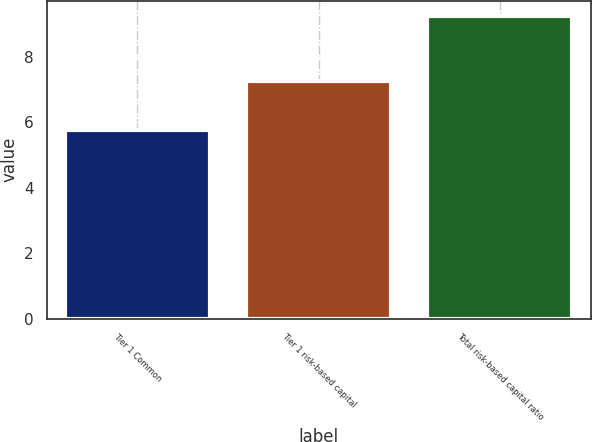Convert chart. <chart><loc_0><loc_0><loc_500><loc_500><bar_chart><fcel>Tier 1 Common<fcel>Tier 1 risk-based capital<fcel>Total risk-based capital ratio<nl><fcel>5.75<fcel>7.25<fcel>9.25<nl></chart> 